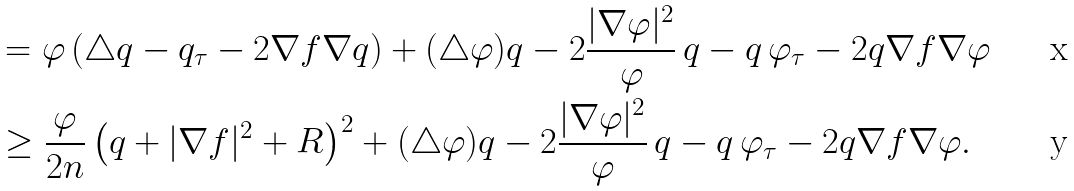Convert formula to latex. <formula><loc_0><loc_0><loc_500><loc_500>& = \varphi \left ( \triangle q - q _ { \tau } - 2 \nabla f \nabla q \right ) + ( \triangle \varphi ) q - 2 \frac { | \nabla \varphi | ^ { 2 } } { \varphi } \, q - q \, \varphi _ { \tau } - 2 q \nabla f \nabla \varphi \\ & \geq \frac { \varphi } { 2 n } \left ( q + | \nabla f | ^ { 2 } + R \right ) ^ { 2 } + ( \triangle \varphi ) q - 2 \frac { | \nabla \varphi | ^ { 2 } } { \varphi } \, q - q \, \varphi _ { \tau } - 2 q \nabla f \nabla \varphi .</formula> 